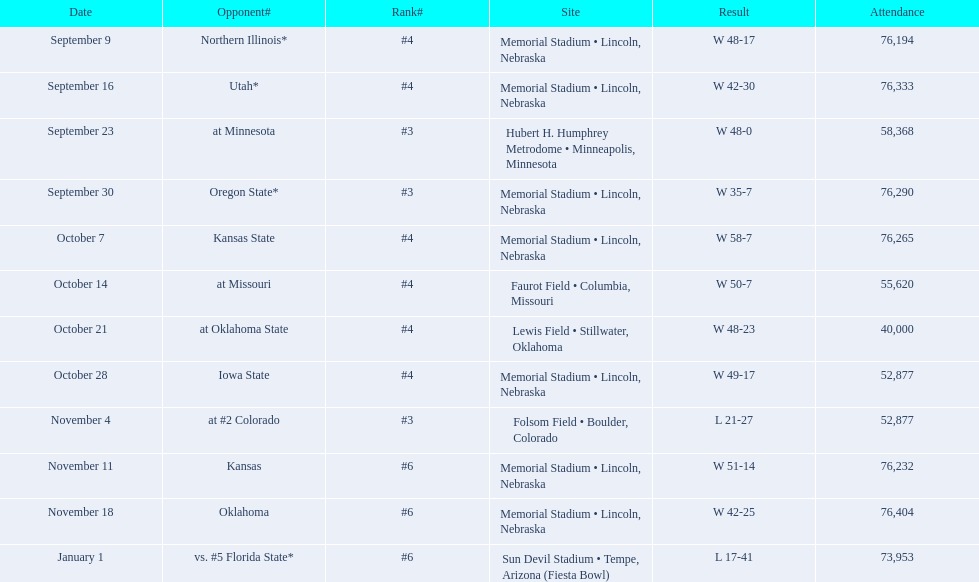Which competitors did the nebraska cornhuskers tally under 40 points against? Oregon State*, at #2 Colorado, vs. #5 Florida State*. Among these games, which ones attracted more than 70,000 spectators? Oregon State*, vs. #5 Florida State*. Which of these opponents were they victorious against? Oregon State*. What was the attendance count at that game? 76,290. 